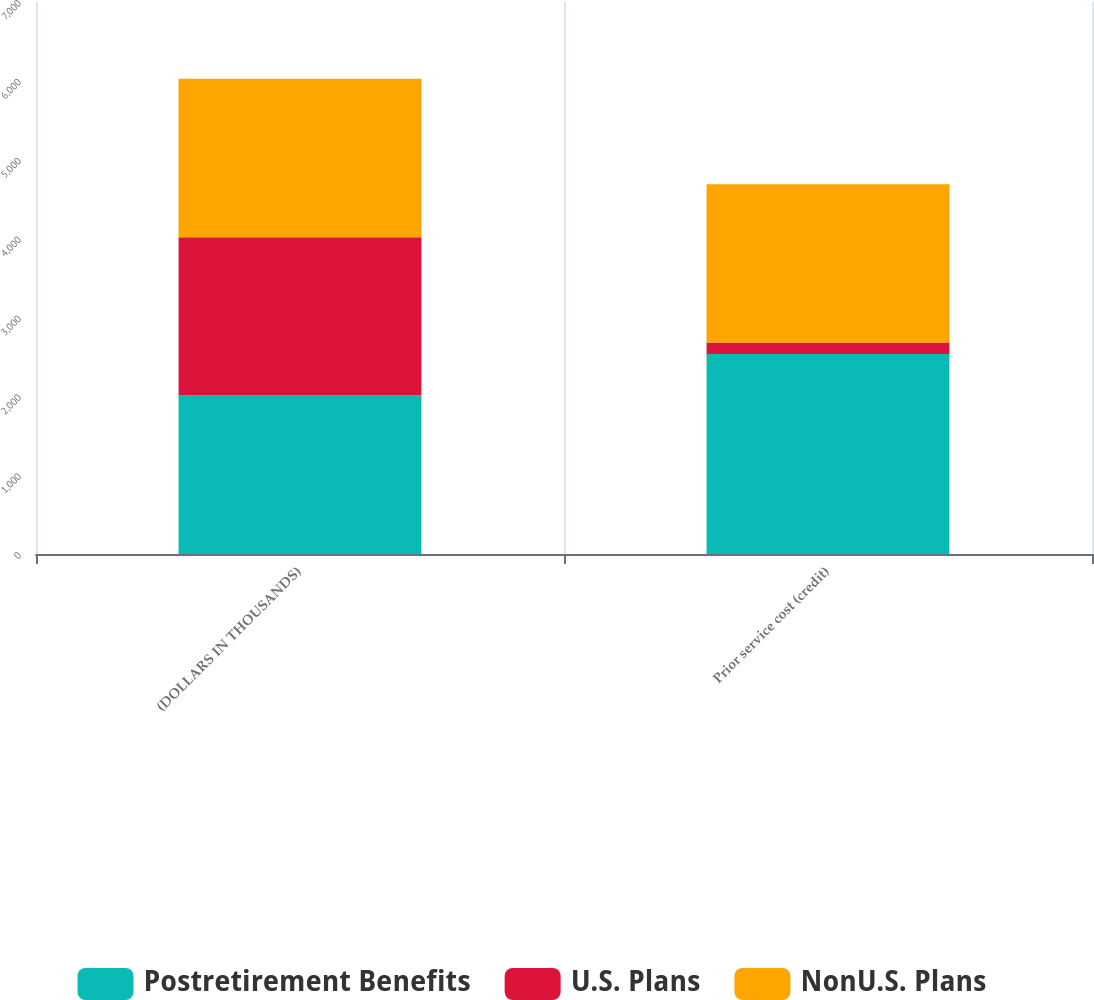Convert chart to OTSL. <chart><loc_0><loc_0><loc_500><loc_500><stacked_bar_chart><ecel><fcel>(DOLLARS IN THOUSANDS)<fcel>Prior service cost (credit)<nl><fcel>Postretirement Benefits<fcel>2009<fcel>2536<nl><fcel>U.S. Plans<fcel>2009<fcel>145<nl><fcel>NonU.S. Plans<fcel>2009<fcel>2009<nl></chart> 